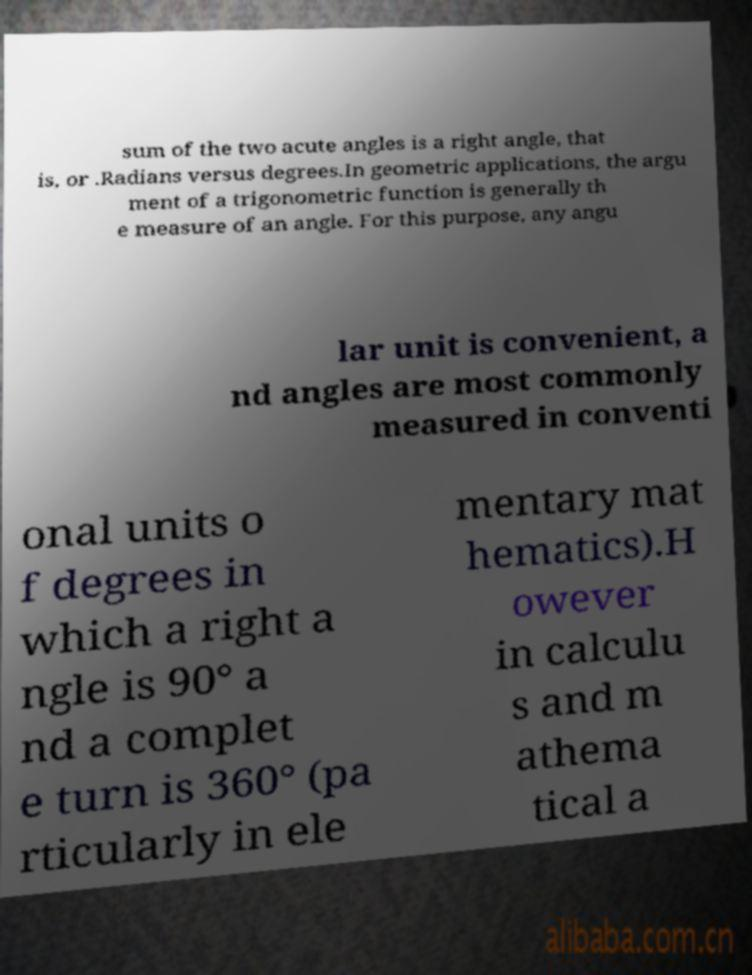Please identify and transcribe the text found in this image. sum of the two acute angles is a right angle, that is, or .Radians versus degrees.In geometric applications, the argu ment of a trigonometric function is generally th e measure of an angle. For this purpose, any angu lar unit is convenient, a nd angles are most commonly measured in conventi onal units o f degrees in which a right a ngle is 90° a nd a complet e turn is 360° (pa rticularly in ele mentary mat hematics).H owever in calculu s and m athema tical a 